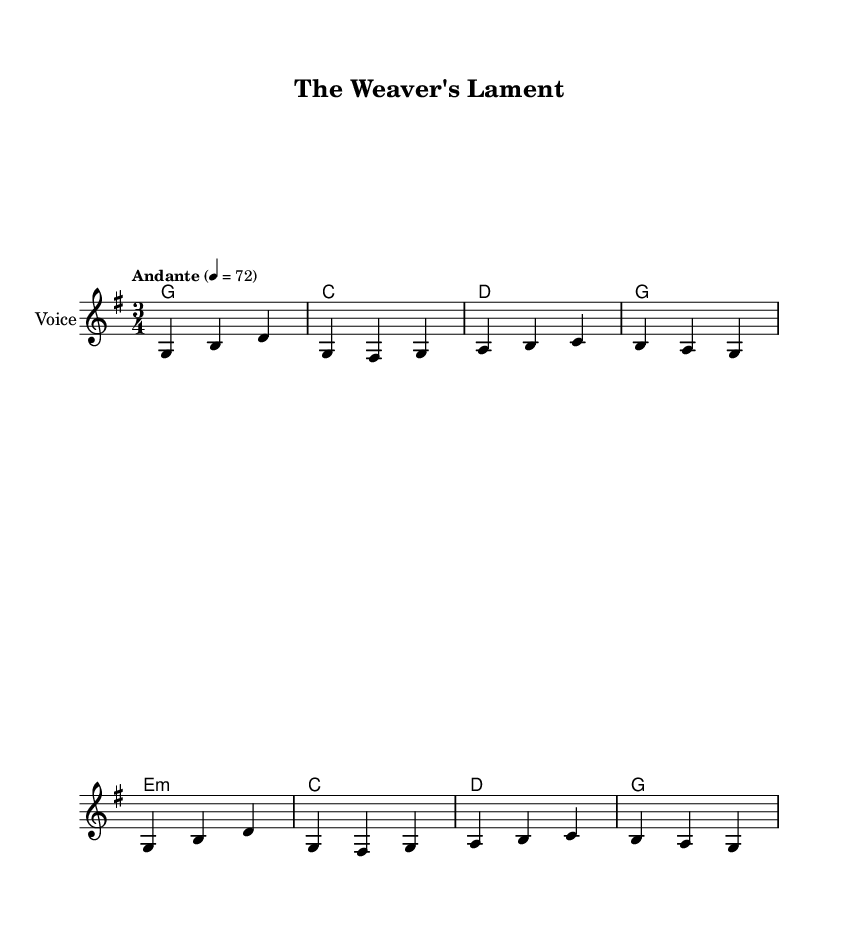What is the key signature of this music? The key signature is G major, which has one sharp (F#). This can be confirmed by examining the key signature indicated at the beginning of the score.
Answer: G major What is the time signature of this piece? The time signature is 3/4, indicated in the score where it states "3/4." This means there are three beats per measure and the quarter note receives one beat.
Answer: 3/4 What is the tempo marking for this piece? The tempo marking is "Andante," which indicates a moderate pace. This is found in the tempo indication at the start of the score, where it mentions "Andante" and sets the metronome mark at 72 beats per minute.
Answer: Andante How many measures are in the verse? The verse consists of 4 measures, as seen when counting the bars in the melody section that corresponds with the provided lyrics. Each vertical line indicates the end of a measure.
Answer: 4 What is the chord progression used in the harmonies? The chord progression is G, C, D, G, E minor, C, D, G. This can be determined by looking at the chord names listed beneath the staff, which show the chords played with their corresponding measures.
Answer: G, C, D, G, E minor, C, D, G What theme do the lyrics in the verse focus on? The lyrics in the verse focus on textiles, specifically weaving, as indicated by phrases like “the looms do softly hum,” suggesting a connection to fabric and weaving traditions characteristic of Appalachian culture.
Answer: Weaving 